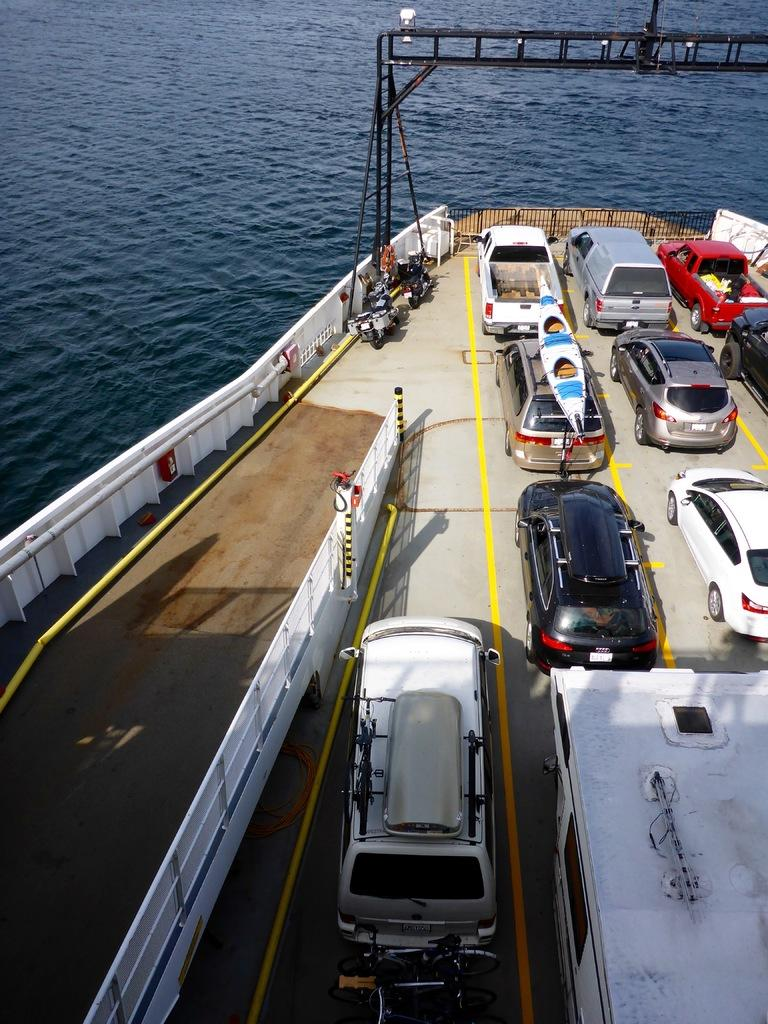What type of vehicles are in the boat in the image? There are cars in the boat in the image. Where is the boat located? The boat is on the water. What color is the car in front? The car in front is white in color. What type of bucket can be seen in the image? There is no bucket present in the image. Can you hear the sound of bears in the image? There is no sound or bears present in the image. 